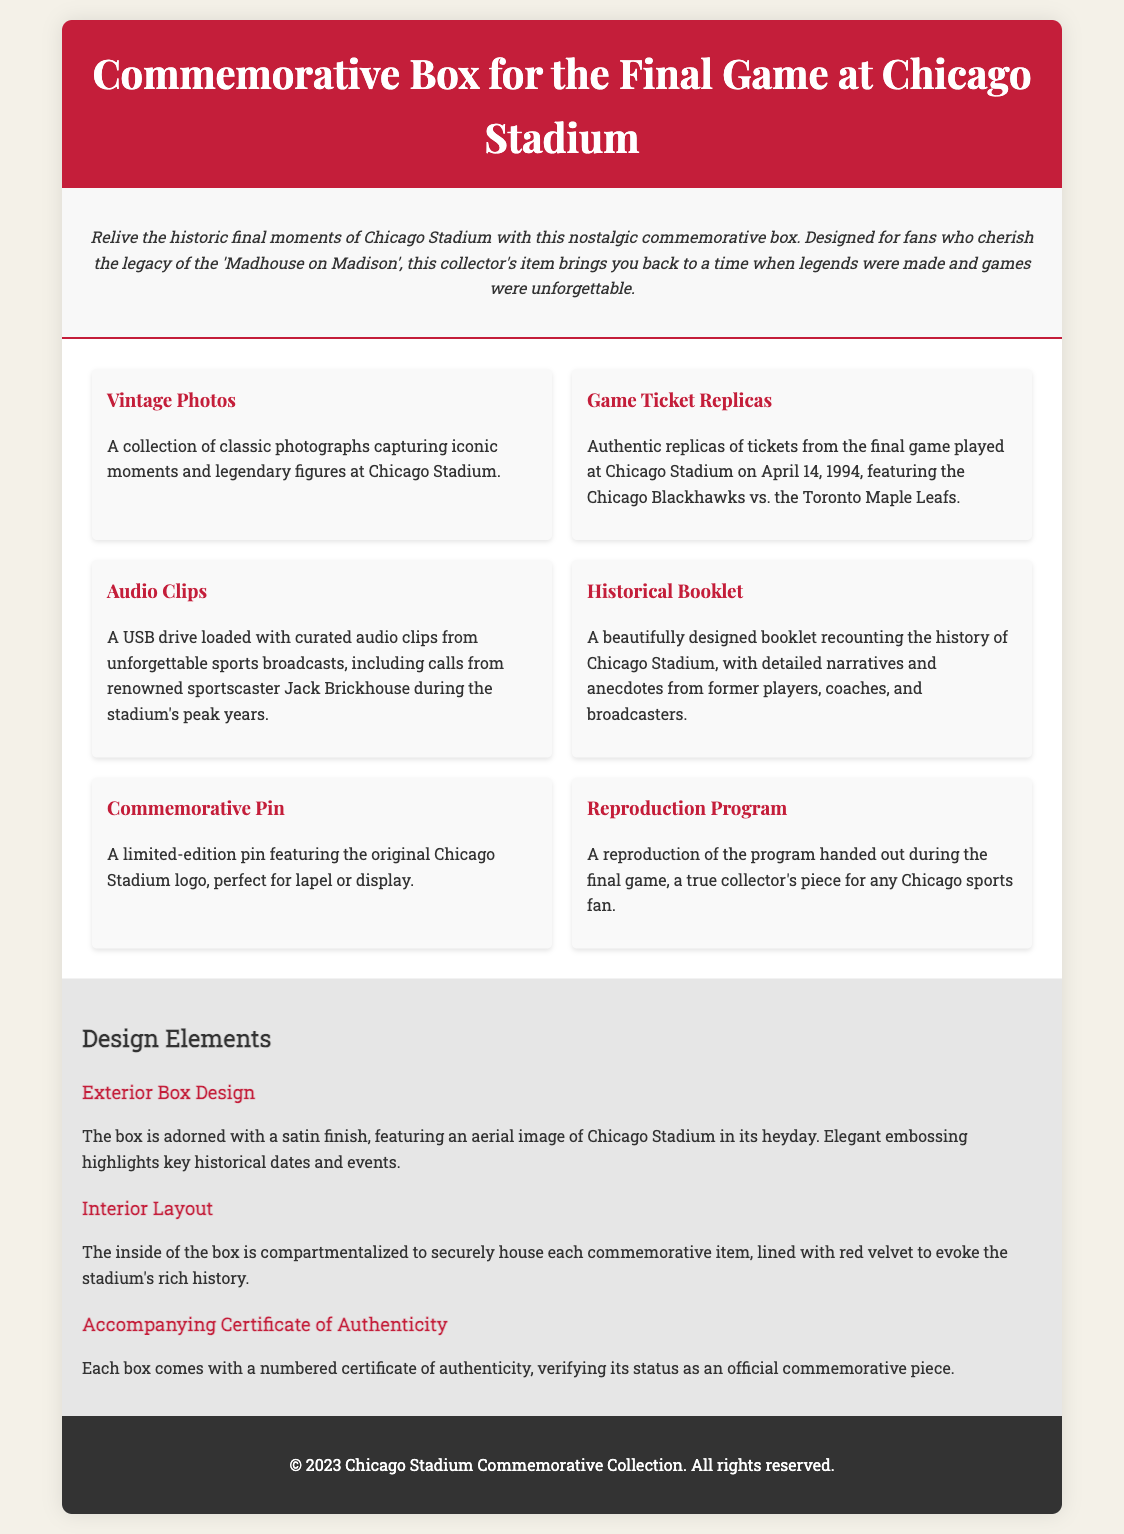what is included in the commemorative box? The document lists several items included in the commemorative box, such as vintage photos, game ticket replicas, and audio clips.
Answer: vintage photos, game ticket replicas, audio clips, historical booklet, commemorative pin, reproduction program when was the final game played at Chicago Stadium? The document specifies the date of the final game played at Chicago Stadium.
Answer: April 14, 1994 who was the renowned sportscaster mentioned in the audio clips section? The document names a specific sportscaster associated with the audio clips.
Answer: Jack Brickhouse what is the exterior design of the box? The document describes the exterior design of the box, including features and finishes.
Answer: satin finish, aerial image of Chicago Stadium how is the interior of the box designed? The document explains the interior layout of the box and its materials.
Answer: compartmentalized, lined with red velvet what does the certificate that comes with the box verify? The document states what the certificate signifies regarding the commemorative box.
Answer: authenticity which team did the Chicago Blackhawks play during the final game? The document mentions the opposing team in the final game at Chicago Stadium.
Answer: Toronto Maple Leafs how many items are listed in the content section? The document lists the number of distinct items featured in the content section.
Answer: six 